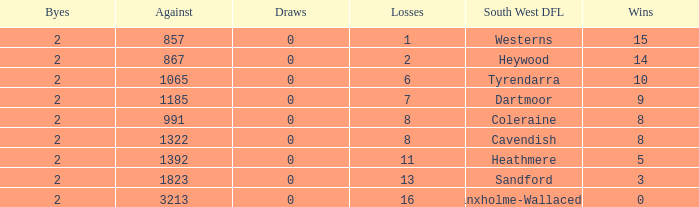Which Losses have a South West DFL of branxholme-wallacedale, and less than 2 Byes? None. 